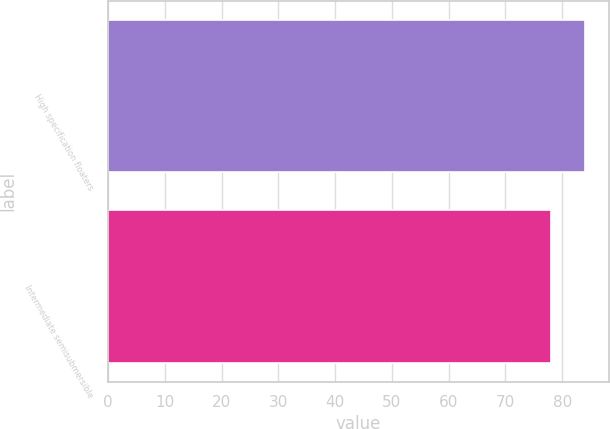Convert chart to OTSL. <chart><loc_0><loc_0><loc_500><loc_500><bar_chart><fcel>High specification floaters<fcel>Intermediate semisubmersible<nl><fcel>84<fcel>78<nl></chart> 